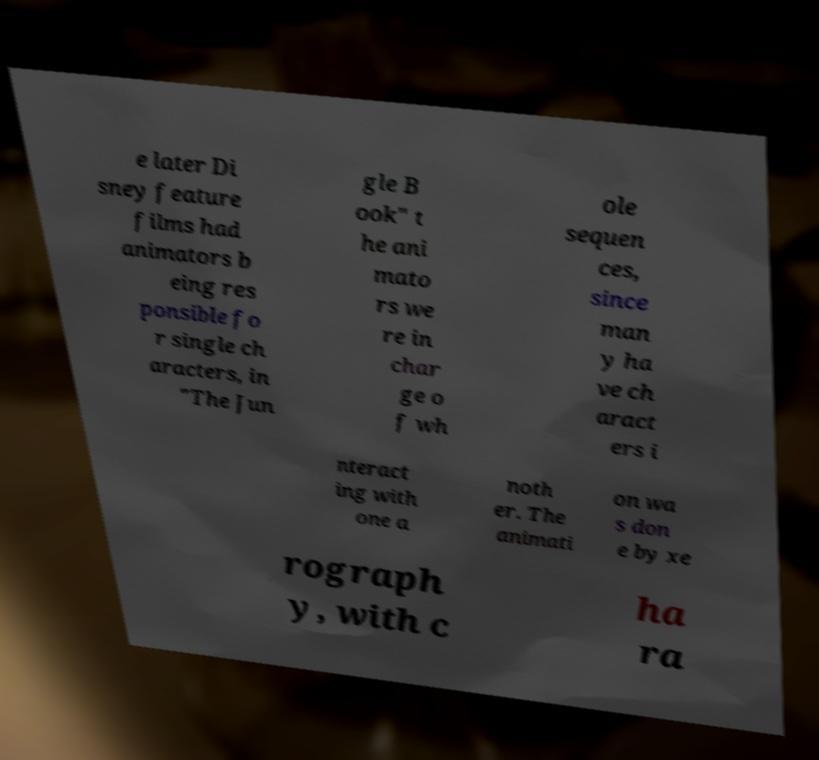Can you accurately transcribe the text from the provided image for me? e later Di sney feature films had animators b eing res ponsible fo r single ch aracters, in "The Jun gle B ook" t he ani mato rs we re in char ge o f wh ole sequen ces, since man y ha ve ch aract ers i nteract ing with one a noth er. The animati on wa s don e by xe rograph y, with c ha ra 